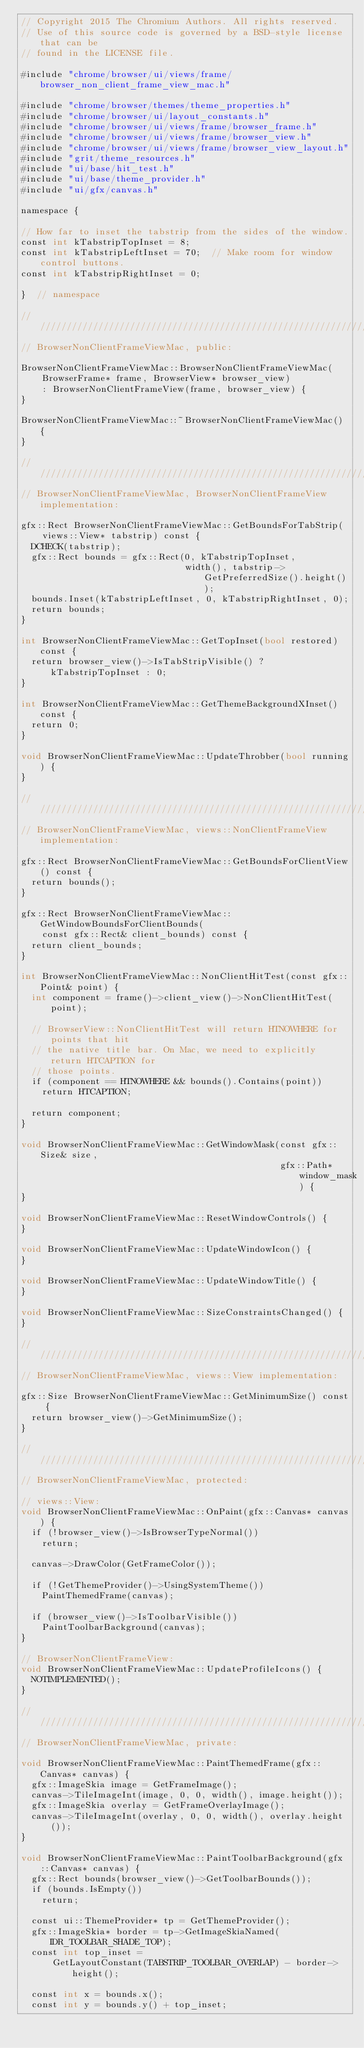<code> <loc_0><loc_0><loc_500><loc_500><_ObjectiveC_>// Copyright 2015 The Chromium Authors. All rights reserved.
// Use of this source code is governed by a BSD-style license that can be
// found in the LICENSE file.

#include "chrome/browser/ui/views/frame/browser_non_client_frame_view_mac.h"

#include "chrome/browser/themes/theme_properties.h"
#include "chrome/browser/ui/layout_constants.h"
#include "chrome/browser/ui/views/frame/browser_frame.h"
#include "chrome/browser/ui/views/frame/browser_view.h"
#include "chrome/browser/ui/views/frame/browser_view_layout.h"
#include "grit/theme_resources.h"
#include "ui/base/hit_test.h"
#include "ui/base/theme_provider.h"
#include "ui/gfx/canvas.h"

namespace {

// How far to inset the tabstrip from the sides of the window.
const int kTabstripTopInset = 8;
const int kTabstripLeftInset = 70;  // Make room for window control buttons.
const int kTabstripRightInset = 0;

}  // namespace

///////////////////////////////////////////////////////////////////////////////
// BrowserNonClientFrameViewMac, public:

BrowserNonClientFrameViewMac::BrowserNonClientFrameViewMac(
    BrowserFrame* frame, BrowserView* browser_view)
    : BrowserNonClientFrameView(frame, browser_view) {
}

BrowserNonClientFrameViewMac::~BrowserNonClientFrameViewMac() {
}

///////////////////////////////////////////////////////////////////////////////
// BrowserNonClientFrameViewMac, BrowserNonClientFrameView implementation:

gfx::Rect BrowserNonClientFrameViewMac::GetBoundsForTabStrip(
    views::View* tabstrip) const {
  DCHECK(tabstrip);
  gfx::Rect bounds = gfx::Rect(0, kTabstripTopInset,
                               width(), tabstrip->GetPreferredSize().height());
  bounds.Inset(kTabstripLeftInset, 0, kTabstripRightInset, 0);
  return bounds;
}

int BrowserNonClientFrameViewMac::GetTopInset(bool restored) const {
  return browser_view()->IsTabStripVisible() ? kTabstripTopInset : 0;
}

int BrowserNonClientFrameViewMac::GetThemeBackgroundXInset() const {
  return 0;
}

void BrowserNonClientFrameViewMac::UpdateThrobber(bool running) {
}

///////////////////////////////////////////////////////////////////////////////
// BrowserNonClientFrameViewMac, views::NonClientFrameView implementation:

gfx::Rect BrowserNonClientFrameViewMac::GetBoundsForClientView() const {
  return bounds();
}

gfx::Rect BrowserNonClientFrameViewMac::GetWindowBoundsForClientBounds(
    const gfx::Rect& client_bounds) const {
  return client_bounds;
}

int BrowserNonClientFrameViewMac::NonClientHitTest(const gfx::Point& point) {
  int component = frame()->client_view()->NonClientHitTest(point);

  // BrowserView::NonClientHitTest will return HTNOWHERE for points that hit
  // the native title bar. On Mac, we need to explicitly return HTCAPTION for
  // those points.
  if (component == HTNOWHERE && bounds().Contains(point))
    return HTCAPTION;

  return component;
}

void BrowserNonClientFrameViewMac::GetWindowMask(const gfx::Size& size,
                                                 gfx::Path* window_mask) {
}

void BrowserNonClientFrameViewMac::ResetWindowControls() {
}

void BrowserNonClientFrameViewMac::UpdateWindowIcon() {
}

void BrowserNonClientFrameViewMac::UpdateWindowTitle() {
}

void BrowserNonClientFrameViewMac::SizeConstraintsChanged() {
}

///////////////////////////////////////////////////////////////////////////////
// BrowserNonClientFrameViewMac, views::View implementation:

gfx::Size BrowserNonClientFrameViewMac::GetMinimumSize() const {
  return browser_view()->GetMinimumSize();
}

///////////////////////////////////////////////////////////////////////////////
// BrowserNonClientFrameViewMac, protected:

// views::View:
void BrowserNonClientFrameViewMac::OnPaint(gfx::Canvas* canvas) {
  if (!browser_view()->IsBrowserTypeNormal())
    return;

  canvas->DrawColor(GetFrameColor());

  if (!GetThemeProvider()->UsingSystemTheme())
    PaintThemedFrame(canvas);

  if (browser_view()->IsToolbarVisible())
    PaintToolbarBackground(canvas);
}

// BrowserNonClientFrameView:
void BrowserNonClientFrameViewMac::UpdateProfileIcons() {
  NOTIMPLEMENTED();
}

///////////////////////////////////////////////////////////////////////////////
// BrowserNonClientFrameViewMac, private:

void BrowserNonClientFrameViewMac::PaintThemedFrame(gfx::Canvas* canvas) {
  gfx::ImageSkia image = GetFrameImage();
  canvas->TileImageInt(image, 0, 0, width(), image.height());
  gfx::ImageSkia overlay = GetFrameOverlayImage();
  canvas->TileImageInt(overlay, 0, 0, width(), overlay.height());
}

void BrowserNonClientFrameViewMac::PaintToolbarBackground(gfx::Canvas* canvas) {
  gfx::Rect bounds(browser_view()->GetToolbarBounds());
  if (bounds.IsEmpty())
    return;

  const ui::ThemeProvider* tp = GetThemeProvider();
  gfx::ImageSkia* border = tp->GetImageSkiaNamed(IDR_TOOLBAR_SHADE_TOP);
  const int top_inset =
      GetLayoutConstant(TABSTRIP_TOOLBAR_OVERLAP) - border->height();

  const int x = bounds.x();
  const int y = bounds.y() + top_inset;</code> 